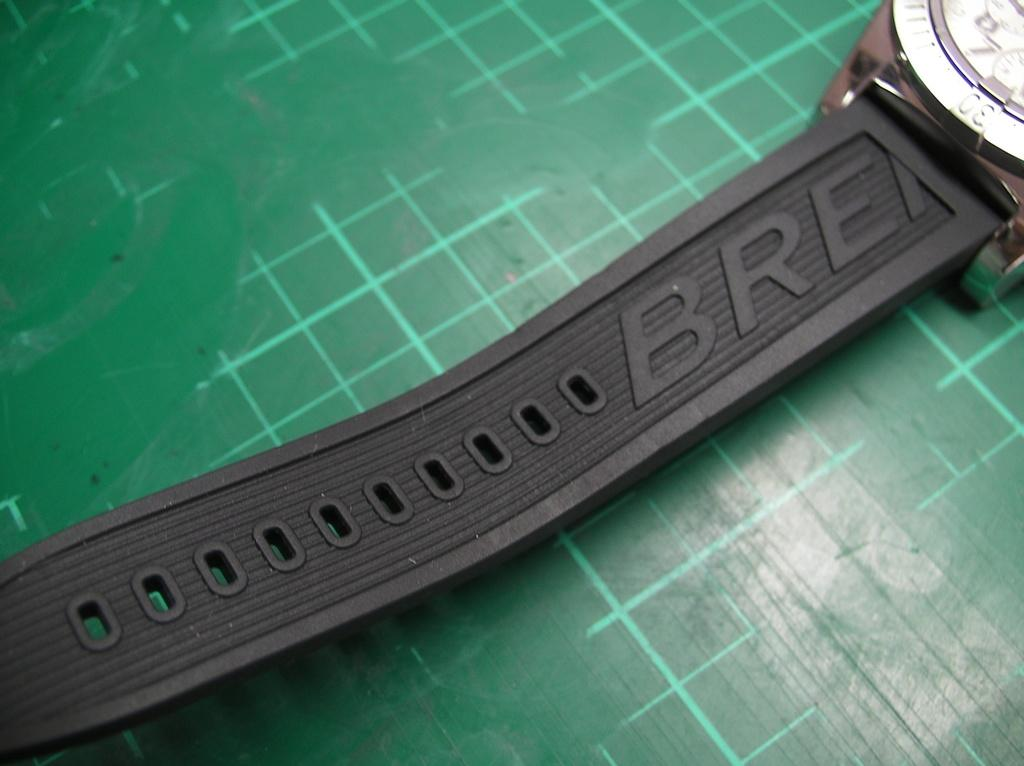<image>
Share a concise interpretation of the image provided. Black strap of a watch named "BRE" on a green tabletop. 